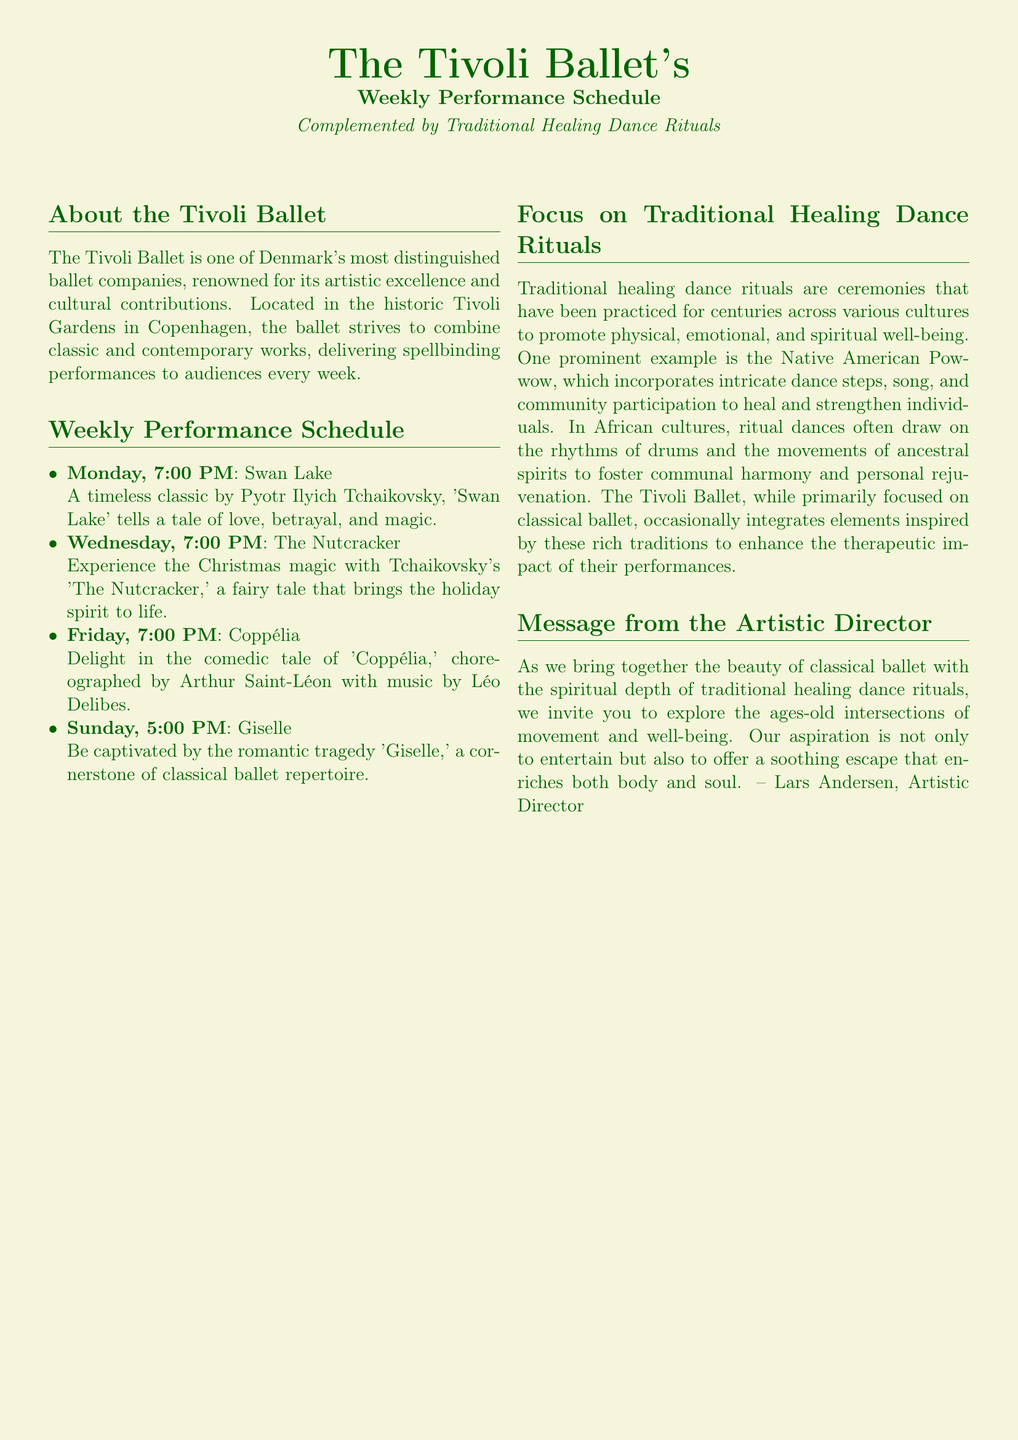What is the location of The Tivoli Ballet? The location of The Tivoli Ballet is mentioned in the document as Tivoli Gardens in Copenhagen.
Answer: Tivoli Gardens, Copenhagen Who is the composer of 'Swan Lake'? The document states that 'Swan Lake' is a timeless classic by Pyotr Ilyich Tchaikovsky.
Answer: Pyotr Ilyich Tchaikovsky What day and time is 'The Nutcracker' performed? The document specifies that 'The Nutcracker' is performed on Wednesday at 7:00 PM.
Answer: Wednesday, 7:00 PM What type of well-being do traditional healing dance rituals promote? The document indicates that traditional healing dance rituals promote physical, emotional, and spiritual well-being.
Answer: Physical, emotional, and spiritual What is the name of the Artistic Director? The name of the Artistic Director is provided in the message as Lars Andersen.
Answer: Lars Andersen How many performances are scheduled in a week? The document lists four performances scheduled throughout the week.
Answer: Four What cultural example of healing dance is mentioned? The document refers to the Native American Powwow as a prominent example of a traditional healing dance.
Answer: Native American Powwow What is the theme of 'Giselle'? The theme of 'Giselle' is described as a romantic tragedy in the document.
Answer: Romantic tragedy 